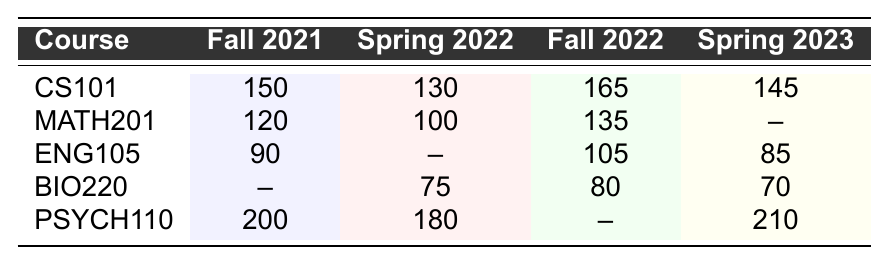What is the enrollment number for CS101 in Fall 2022? The table shows that CS101 has an enrollment of 165 in Fall 2022.
Answer: 165 How many students enrolled in MATH201 during Spring 2022? The enrollment count for MATH201 in Spring 2022 is 100 as shown in the table.
Answer: 100 Which course had the highest enrollment in Fall 2021? From the table, PSYCH110 had the highest enrollment with 200 students in Fall 2021.
Answer: PSYCH110 What is the total enrollment for ENG105 across all available semesters? The enrollments for ENG105 are 90 (Fall 2021), 105 (Fall 2022), and 85 (Spring 2023). Adding these gives 90 + 105 + 85 = 280, with no data for Spring 2022.
Answer: 280 Did any course experience an increase in enrollment from Fall 2021 to Fall 2022? Comparing the enrollments, CS101 increased from 150 to 165, which is an increase. Other courses either decreased or had missing data.
Answer: Yes What is the average enrollment for PSYCH110 across its recorded semesters? The enrollments for PSYCH110 are 200 (Fall 2021), 180 (Spring 2022), and 210 (Spring 2023). Adding these gives 200 + 180 + 210 = 590, and dividing by 3, the average is 590/3 = 196.67.
Answer: 196.67 Which course had no enrollment data for Spring 2022? The table indicates that ENG105 has no recorded data for Spring 2022.
Answer: ENG105 How does the enrollment for BIO220 in Spring 2023 compare with its enrollment in Fall 2022? BIO220 had 80 enrollments in Fall 2022 and 70 in Spring 2023, showing a decrease of 10 students from Fall to Spring.
Answer: Decreased by 10 Which semester had the least number of enrollments for the course MATH201? MATH201 shows 100 enrollments in Spring 2022, and 120 in Fall 2021, with 135 in Fall 2022. The least is in Spring 2022 with 100.
Answer: Spring 2022 Can we determine the overall trend for student enrollment in ENG105 from Fall 2021 to Spring 2023? Analyzing the revealed data: ENG105 had 90 in Fall 2021, no data in Spring 2022, 105 in Fall 2022, and 85 in Spring 2023. It first rose to 105 and later dropped to 85. The trend is inconsistent.
Answer: Inconsistent trend 